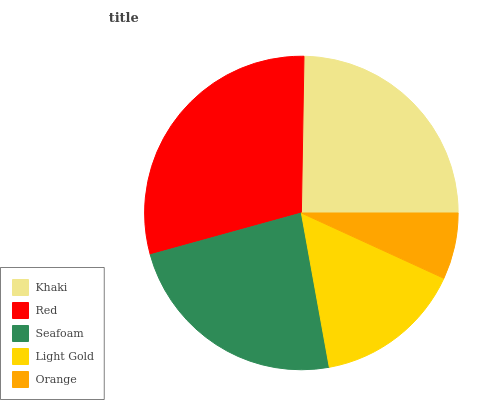Is Orange the minimum?
Answer yes or no. Yes. Is Red the maximum?
Answer yes or no. Yes. Is Seafoam the minimum?
Answer yes or no. No. Is Seafoam the maximum?
Answer yes or no. No. Is Red greater than Seafoam?
Answer yes or no. Yes. Is Seafoam less than Red?
Answer yes or no. Yes. Is Seafoam greater than Red?
Answer yes or no. No. Is Red less than Seafoam?
Answer yes or no. No. Is Seafoam the high median?
Answer yes or no. Yes. Is Seafoam the low median?
Answer yes or no. Yes. Is Orange the high median?
Answer yes or no. No. Is Orange the low median?
Answer yes or no. No. 